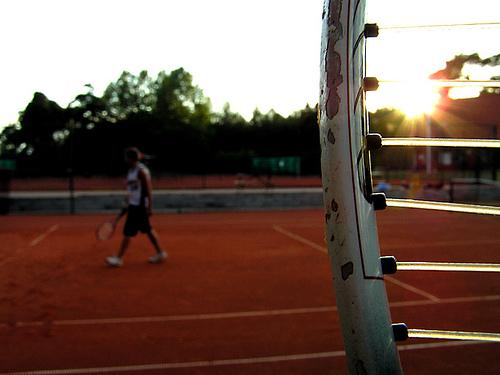What is partially blocking this image? Please explain your reasoning. racket. There is wood with strings on it 